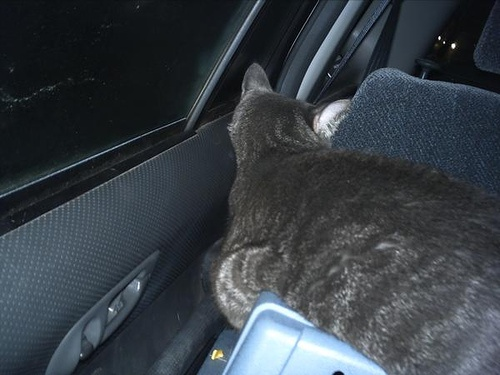Describe the objects in this image and their specific colors. I can see car in black, blue, and darkblue tones and cat in black, gray, and darkgray tones in this image. 